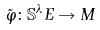Convert formula to latex. <formula><loc_0><loc_0><loc_500><loc_500>\tilde { \varphi } \colon \mathbb { S } ^ { \lambda } E \rightarrow M</formula> 